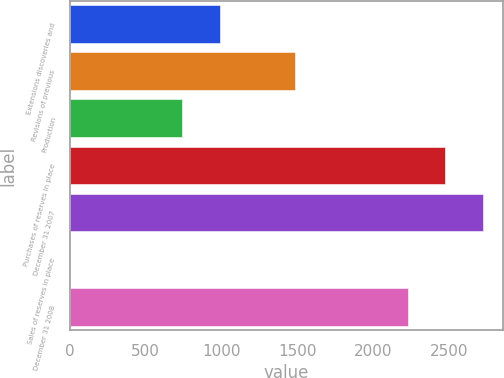Convert chart to OTSL. <chart><loc_0><loc_0><loc_500><loc_500><bar_chart><fcel>Extensions discoveries and<fcel>Revisions of previous<fcel>Production<fcel>Purchases of reserves in place<fcel>December 31 2007<fcel>Sales of reserves in place<fcel>December 31 2008<nl><fcel>990.2<fcel>1484.8<fcel>742.9<fcel>2474<fcel>2721.3<fcel>1<fcel>2226.7<nl></chart> 